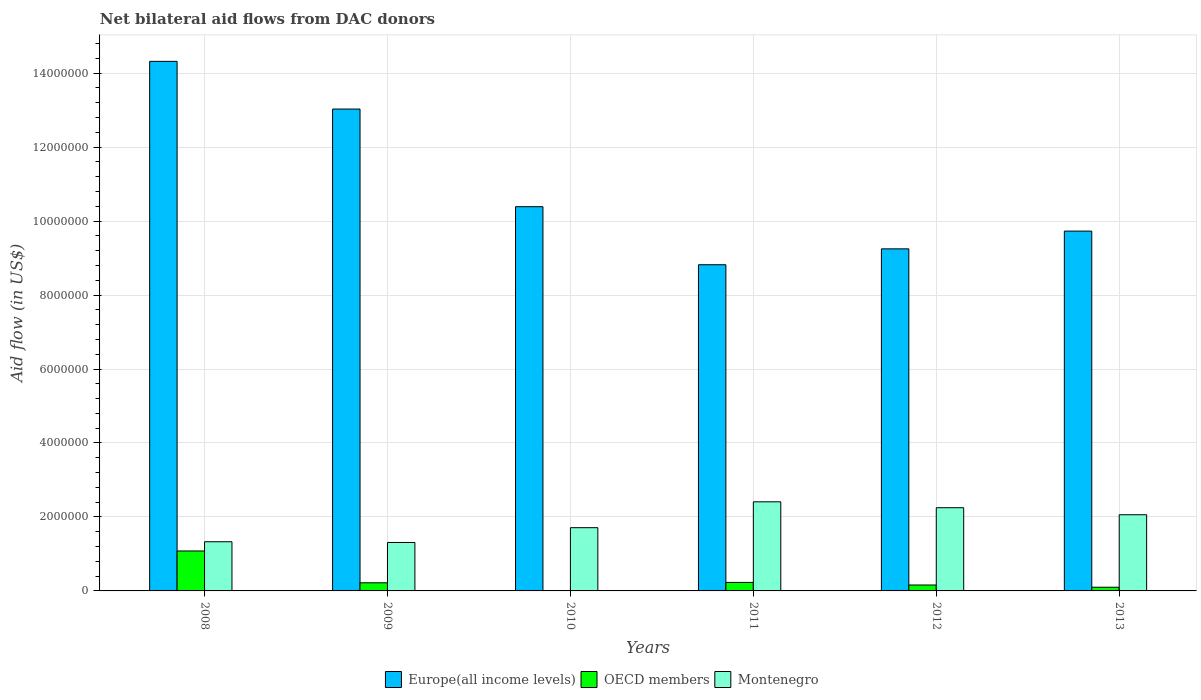How many different coloured bars are there?
Offer a very short reply. 3. How many groups of bars are there?
Offer a terse response. 6. Are the number of bars per tick equal to the number of legend labels?
Your response must be concise. Yes. Are the number of bars on each tick of the X-axis equal?
Your answer should be very brief. Yes. How many bars are there on the 1st tick from the left?
Provide a short and direct response. 3. In how many cases, is the number of bars for a given year not equal to the number of legend labels?
Ensure brevity in your answer.  0. What is the net bilateral aid flow in Europe(all income levels) in 2013?
Your response must be concise. 9.73e+06. Across all years, what is the maximum net bilateral aid flow in OECD members?
Make the answer very short. 1.08e+06. Across all years, what is the minimum net bilateral aid flow in Montenegro?
Offer a very short reply. 1.31e+06. What is the total net bilateral aid flow in Montenegro in the graph?
Keep it short and to the point. 1.11e+07. What is the difference between the net bilateral aid flow in OECD members in 2011 and that in 2013?
Give a very brief answer. 1.30e+05. What is the difference between the net bilateral aid flow in Europe(all income levels) in 2009 and the net bilateral aid flow in Montenegro in 2012?
Your response must be concise. 1.08e+07. In the year 2012, what is the difference between the net bilateral aid flow in OECD members and net bilateral aid flow in Europe(all income levels)?
Provide a short and direct response. -9.09e+06. What is the ratio of the net bilateral aid flow in OECD members in 2011 to that in 2012?
Provide a short and direct response. 1.44. Is the net bilateral aid flow in Montenegro in 2009 less than that in 2012?
Make the answer very short. Yes. Is the difference between the net bilateral aid flow in OECD members in 2008 and 2012 greater than the difference between the net bilateral aid flow in Europe(all income levels) in 2008 and 2012?
Provide a succinct answer. No. What is the difference between the highest and the second highest net bilateral aid flow in OECD members?
Your answer should be compact. 8.50e+05. What is the difference between the highest and the lowest net bilateral aid flow in OECD members?
Provide a succinct answer. 1.07e+06. In how many years, is the net bilateral aid flow in Montenegro greater than the average net bilateral aid flow in Montenegro taken over all years?
Provide a short and direct response. 3. Is the sum of the net bilateral aid flow in Europe(all income levels) in 2011 and 2013 greater than the maximum net bilateral aid flow in OECD members across all years?
Provide a short and direct response. Yes. What does the 3rd bar from the left in 2011 represents?
Your answer should be compact. Montenegro. What does the 3rd bar from the right in 2008 represents?
Give a very brief answer. Europe(all income levels). How many years are there in the graph?
Your response must be concise. 6. What is the difference between two consecutive major ticks on the Y-axis?
Offer a very short reply. 2.00e+06. Are the values on the major ticks of Y-axis written in scientific E-notation?
Offer a terse response. No. Does the graph contain any zero values?
Provide a succinct answer. No. Where does the legend appear in the graph?
Offer a very short reply. Bottom center. How are the legend labels stacked?
Offer a very short reply. Horizontal. What is the title of the graph?
Make the answer very short. Net bilateral aid flows from DAC donors. Does "High income" appear as one of the legend labels in the graph?
Keep it short and to the point. No. What is the label or title of the X-axis?
Your answer should be very brief. Years. What is the label or title of the Y-axis?
Make the answer very short. Aid flow (in US$). What is the Aid flow (in US$) of Europe(all income levels) in 2008?
Make the answer very short. 1.43e+07. What is the Aid flow (in US$) in OECD members in 2008?
Provide a succinct answer. 1.08e+06. What is the Aid flow (in US$) of Montenegro in 2008?
Provide a short and direct response. 1.33e+06. What is the Aid flow (in US$) of Europe(all income levels) in 2009?
Make the answer very short. 1.30e+07. What is the Aid flow (in US$) of Montenegro in 2009?
Offer a terse response. 1.31e+06. What is the Aid flow (in US$) of Europe(all income levels) in 2010?
Keep it short and to the point. 1.04e+07. What is the Aid flow (in US$) in OECD members in 2010?
Your answer should be compact. 10000. What is the Aid flow (in US$) in Montenegro in 2010?
Keep it short and to the point. 1.71e+06. What is the Aid flow (in US$) of Europe(all income levels) in 2011?
Offer a very short reply. 8.82e+06. What is the Aid flow (in US$) in Montenegro in 2011?
Make the answer very short. 2.41e+06. What is the Aid flow (in US$) in Europe(all income levels) in 2012?
Your response must be concise. 9.25e+06. What is the Aid flow (in US$) in OECD members in 2012?
Provide a succinct answer. 1.60e+05. What is the Aid flow (in US$) in Montenegro in 2012?
Keep it short and to the point. 2.25e+06. What is the Aid flow (in US$) of Europe(all income levels) in 2013?
Provide a short and direct response. 9.73e+06. What is the Aid flow (in US$) in OECD members in 2013?
Ensure brevity in your answer.  1.00e+05. What is the Aid flow (in US$) in Montenegro in 2013?
Your answer should be very brief. 2.06e+06. Across all years, what is the maximum Aid flow (in US$) of Europe(all income levels)?
Your answer should be very brief. 1.43e+07. Across all years, what is the maximum Aid flow (in US$) in OECD members?
Your answer should be compact. 1.08e+06. Across all years, what is the maximum Aid flow (in US$) in Montenegro?
Offer a terse response. 2.41e+06. Across all years, what is the minimum Aid flow (in US$) in Europe(all income levels)?
Make the answer very short. 8.82e+06. Across all years, what is the minimum Aid flow (in US$) in OECD members?
Your answer should be very brief. 10000. Across all years, what is the minimum Aid flow (in US$) in Montenegro?
Your answer should be compact. 1.31e+06. What is the total Aid flow (in US$) in Europe(all income levels) in the graph?
Offer a terse response. 6.55e+07. What is the total Aid flow (in US$) in OECD members in the graph?
Make the answer very short. 1.80e+06. What is the total Aid flow (in US$) of Montenegro in the graph?
Provide a short and direct response. 1.11e+07. What is the difference between the Aid flow (in US$) in Europe(all income levels) in 2008 and that in 2009?
Ensure brevity in your answer.  1.29e+06. What is the difference between the Aid flow (in US$) in OECD members in 2008 and that in 2009?
Provide a short and direct response. 8.60e+05. What is the difference between the Aid flow (in US$) in Europe(all income levels) in 2008 and that in 2010?
Provide a short and direct response. 3.93e+06. What is the difference between the Aid flow (in US$) in OECD members in 2008 and that in 2010?
Provide a short and direct response. 1.07e+06. What is the difference between the Aid flow (in US$) in Montenegro in 2008 and that in 2010?
Ensure brevity in your answer.  -3.80e+05. What is the difference between the Aid flow (in US$) of Europe(all income levels) in 2008 and that in 2011?
Give a very brief answer. 5.50e+06. What is the difference between the Aid flow (in US$) in OECD members in 2008 and that in 2011?
Offer a terse response. 8.50e+05. What is the difference between the Aid flow (in US$) in Montenegro in 2008 and that in 2011?
Offer a very short reply. -1.08e+06. What is the difference between the Aid flow (in US$) in Europe(all income levels) in 2008 and that in 2012?
Your answer should be compact. 5.07e+06. What is the difference between the Aid flow (in US$) of OECD members in 2008 and that in 2012?
Provide a short and direct response. 9.20e+05. What is the difference between the Aid flow (in US$) in Montenegro in 2008 and that in 2012?
Your answer should be very brief. -9.20e+05. What is the difference between the Aid flow (in US$) in Europe(all income levels) in 2008 and that in 2013?
Make the answer very short. 4.59e+06. What is the difference between the Aid flow (in US$) of OECD members in 2008 and that in 2013?
Your answer should be very brief. 9.80e+05. What is the difference between the Aid flow (in US$) of Montenegro in 2008 and that in 2013?
Provide a succinct answer. -7.30e+05. What is the difference between the Aid flow (in US$) of Europe(all income levels) in 2009 and that in 2010?
Offer a terse response. 2.64e+06. What is the difference between the Aid flow (in US$) of OECD members in 2009 and that in 2010?
Ensure brevity in your answer.  2.10e+05. What is the difference between the Aid flow (in US$) in Montenegro in 2009 and that in 2010?
Give a very brief answer. -4.00e+05. What is the difference between the Aid flow (in US$) in Europe(all income levels) in 2009 and that in 2011?
Your response must be concise. 4.21e+06. What is the difference between the Aid flow (in US$) of OECD members in 2009 and that in 2011?
Provide a succinct answer. -10000. What is the difference between the Aid flow (in US$) of Montenegro in 2009 and that in 2011?
Offer a very short reply. -1.10e+06. What is the difference between the Aid flow (in US$) of Europe(all income levels) in 2009 and that in 2012?
Your answer should be very brief. 3.78e+06. What is the difference between the Aid flow (in US$) in Montenegro in 2009 and that in 2012?
Your response must be concise. -9.40e+05. What is the difference between the Aid flow (in US$) in Europe(all income levels) in 2009 and that in 2013?
Provide a short and direct response. 3.30e+06. What is the difference between the Aid flow (in US$) in Montenegro in 2009 and that in 2013?
Offer a very short reply. -7.50e+05. What is the difference between the Aid flow (in US$) of Europe(all income levels) in 2010 and that in 2011?
Keep it short and to the point. 1.57e+06. What is the difference between the Aid flow (in US$) of Montenegro in 2010 and that in 2011?
Your response must be concise. -7.00e+05. What is the difference between the Aid flow (in US$) in Europe(all income levels) in 2010 and that in 2012?
Offer a terse response. 1.14e+06. What is the difference between the Aid flow (in US$) of Montenegro in 2010 and that in 2012?
Keep it short and to the point. -5.40e+05. What is the difference between the Aid flow (in US$) of Montenegro in 2010 and that in 2013?
Provide a short and direct response. -3.50e+05. What is the difference between the Aid flow (in US$) of Europe(all income levels) in 2011 and that in 2012?
Give a very brief answer. -4.30e+05. What is the difference between the Aid flow (in US$) of OECD members in 2011 and that in 2012?
Ensure brevity in your answer.  7.00e+04. What is the difference between the Aid flow (in US$) in Montenegro in 2011 and that in 2012?
Make the answer very short. 1.60e+05. What is the difference between the Aid flow (in US$) of Europe(all income levels) in 2011 and that in 2013?
Your response must be concise. -9.10e+05. What is the difference between the Aid flow (in US$) in OECD members in 2011 and that in 2013?
Give a very brief answer. 1.30e+05. What is the difference between the Aid flow (in US$) of Europe(all income levels) in 2012 and that in 2013?
Your response must be concise. -4.80e+05. What is the difference between the Aid flow (in US$) of Montenegro in 2012 and that in 2013?
Your response must be concise. 1.90e+05. What is the difference between the Aid flow (in US$) in Europe(all income levels) in 2008 and the Aid flow (in US$) in OECD members in 2009?
Make the answer very short. 1.41e+07. What is the difference between the Aid flow (in US$) of Europe(all income levels) in 2008 and the Aid flow (in US$) of Montenegro in 2009?
Offer a terse response. 1.30e+07. What is the difference between the Aid flow (in US$) in OECD members in 2008 and the Aid flow (in US$) in Montenegro in 2009?
Your answer should be very brief. -2.30e+05. What is the difference between the Aid flow (in US$) in Europe(all income levels) in 2008 and the Aid flow (in US$) in OECD members in 2010?
Provide a succinct answer. 1.43e+07. What is the difference between the Aid flow (in US$) in Europe(all income levels) in 2008 and the Aid flow (in US$) in Montenegro in 2010?
Keep it short and to the point. 1.26e+07. What is the difference between the Aid flow (in US$) in OECD members in 2008 and the Aid flow (in US$) in Montenegro in 2010?
Offer a terse response. -6.30e+05. What is the difference between the Aid flow (in US$) of Europe(all income levels) in 2008 and the Aid flow (in US$) of OECD members in 2011?
Provide a succinct answer. 1.41e+07. What is the difference between the Aid flow (in US$) in Europe(all income levels) in 2008 and the Aid flow (in US$) in Montenegro in 2011?
Give a very brief answer. 1.19e+07. What is the difference between the Aid flow (in US$) in OECD members in 2008 and the Aid flow (in US$) in Montenegro in 2011?
Keep it short and to the point. -1.33e+06. What is the difference between the Aid flow (in US$) in Europe(all income levels) in 2008 and the Aid flow (in US$) in OECD members in 2012?
Give a very brief answer. 1.42e+07. What is the difference between the Aid flow (in US$) in Europe(all income levels) in 2008 and the Aid flow (in US$) in Montenegro in 2012?
Provide a succinct answer. 1.21e+07. What is the difference between the Aid flow (in US$) in OECD members in 2008 and the Aid flow (in US$) in Montenegro in 2012?
Your response must be concise. -1.17e+06. What is the difference between the Aid flow (in US$) in Europe(all income levels) in 2008 and the Aid flow (in US$) in OECD members in 2013?
Your answer should be compact. 1.42e+07. What is the difference between the Aid flow (in US$) of Europe(all income levels) in 2008 and the Aid flow (in US$) of Montenegro in 2013?
Give a very brief answer. 1.23e+07. What is the difference between the Aid flow (in US$) of OECD members in 2008 and the Aid flow (in US$) of Montenegro in 2013?
Provide a short and direct response. -9.80e+05. What is the difference between the Aid flow (in US$) in Europe(all income levels) in 2009 and the Aid flow (in US$) in OECD members in 2010?
Offer a very short reply. 1.30e+07. What is the difference between the Aid flow (in US$) in Europe(all income levels) in 2009 and the Aid flow (in US$) in Montenegro in 2010?
Your response must be concise. 1.13e+07. What is the difference between the Aid flow (in US$) in OECD members in 2009 and the Aid flow (in US$) in Montenegro in 2010?
Provide a succinct answer. -1.49e+06. What is the difference between the Aid flow (in US$) of Europe(all income levels) in 2009 and the Aid flow (in US$) of OECD members in 2011?
Provide a short and direct response. 1.28e+07. What is the difference between the Aid flow (in US$) in Europe(all income levels) in 2009 and the Aid flow (in US$) in Montenegro in 2011?
Your answer should be compact. 1.06e+07. What is the difference between the Aid flow (in US$) in OECD members in 2009 and the Aid flow (in US$) in Montenegro in 2011?
Offer a very short reply. -2.19e+06. What is the difference between the Aid flow (in US$) of Europe(all income levels) in 2009 and the Aid flow (in US$) of OECD members in 2012?
Your answer should be compact. 1.29e+07. What is the difference between the Aid flow (in US$) of Europe(all income levels) in 2009 and the Aid flow (in US$) of Montenegro in 2012?
Offer a terse response. 1.08e+07. What is the difference between the Aid flow (in US$) in OECD members in 2009 and the Aid flow (in US$) in Montenegro in 2012?
Ensure brevity in your answer.  -2.03e+06. What is the difference between the Aid flow (in US$) in Europe(all income levels) in 2009 and the Aid flow (in US$) in OECD members in 2013?
Your answer should be compact. 1.29e+07. What is the difference between the Aid flow (in US$) in Europe(all income levels) in 2009 and the Aid flow (in US$) in Montenegro in 2013?
Offer a very short reply. 1.10e+07. What is the difference between the Aid flow (in US$) in OECD members in 2009 and the Aid flow (in US$) in Montenegro in 2013?
Your answer should be very brief. -1.84e+06. What is the difference between the Aid flow (in US$) in Europe(all income levels) in 2010 and the Aid flow (in US$) in OECD members in 2011?
Make the answer very short. 1.02e+07. What is the difference between the Aid flow (in US$) of Europe(all income levels) in 2010 and the Aid flow (in US$) of Montenegro in 2011?
Offer a terse response. 7.98e+06. What is the difference between the Aid flow (in US$) of OECD members in 2010 and the Aid flow (in US$) of Montenegro in 2011?
Your answer should be compact. -2.40e+06. What is the difference between the Aid flow (in US$) of Europe(all income levels) in 2010 and the Aid flow (in US$) of OECD members in 2012?
Give a very brief answer. 1.02e+07. What is the difference between the Aid flow (in US$) of Europe(all income levels) in 2010 and the Aid flow (in US$) of Montenegro in 2012?
Your answer should be very brief. 8.14e+06. What is the difference between the Aid flow (in US$) of OECD members in 2010 and the Aid flow (in US$) of Montenegro in 2012?
Make the answer very short. -2.24e+06. What is the difference between the Aid flow (in US$) in Europe(all income levels) in 2010 and the Aid flow (in US$) in OECD members in 2013?
Provide a succinct answer. 1.03e+07. What is the difference between the Aid flow (in US$) of Europe(all income levels) in 2010 and the Aid flow (in US$) of Montenegro in 2013?
Give a very brief answer. 8.33e+06. What is the difference between the Aid flow (in US$) of OECD members in 2010 and the Aid flow (in US$) of Montenegro in 2013?
Ensure brevity in your answer.  -2.05e+06. What is the difference between the Aid flow (in US$) of Europe(all income levels) in 2011 and the Aid flow (in US$) of OECD members in 2012?
Ensure brevity in your answer.  8.66e+06. What is the difference between the Aid flow (in US$) of Europe(all income levels) in 2011 and the Aid flow (in US$) of Montenegro in 2012?
Make the answer very short. 6.57e+06. What is the difference between the Aid flow (in US$) of OECD members in 2011 and the Aid flow (in US$) of Montenegro in 2012?
Ensure brevity in your answer.  -2.02e+06. What is the difference between the Aid flow (in US$) of Europe(all income levels) in 2011 and the Aid flow (in US$) of OECD members in 2013?
Give a very brief answer. 8.72e+06. What is the difference between the Aid flow (in US$) in Europe(all income levels) in 2011 and the Aid flow (in US$) in Montenegro in 2013?
Your answer should be compact. 6.76e+06. What is the difference between the Aid flow (in US$) in OECD members in 2011 and the Aid flow (in US$) in Montenegro in 2013?
Provide a succinct answer. -1.83e+06. What is the difference between the Aid flow (in US$) in Europe(all income levels) in 2012 and the Aid flow (in US$) in OECD members in 2013?
Provide a short and direct response. 9.15e+06. What is the difference between the Aid flow (in US$) in Europe(all income levels) in 2012 and the Aid flow (in US$) in Montenegro in 2013?
Your response must be concise. 7.19e+06. What is the difference between the Aid flow (in US$) of OECD members in 2012 and the Aid flow (in US$) of Montenegro in 2013?
Keep it short and to the point. -1.90e+06. What is the average Aid flow (in US$) of Europe(all income levels) per year?
Make the answer very short. 1.09e+07. What is the average Aid flow (in US$) of OECD members per year?
Keep it short and to the point. 3.00e+05. What is the average Aid flow (in US$) of Montenegro per year?
Your answer should be very brief. 1.84e+06. In the year 2008, what is the difference between the Aid flow (in US$) of Europe(all income levels) and Aid flow (in US$) of OECD members?
Provide a succinct answer. 1.32e+07. In the year 2008, what is the difference between the Aid flow (in US$) in Europe(all income levels) and Aid flow (in US$) in Montenegro?
Offer a very short reply. 1.30e+07. In the year 2009, what is the difference between the Aid flow (in US$) in Europe(all income levels) and Aid flow (in US$) in OECD members?
Make the answer very short. 1.28e+07. In the year 2009, what is the difference between the Aid flow (in US$) in Europe(all income levels) and Aid flow (in US$) in Montenegro?
Give a very brief answer. 1.17e+07. In the year 2009, what is the difference between the Aid flow (in US$) of OECD members and Aid flow (in US$) of Montenegro?
Give a very brief answer. -1.09e+06. In the year 2010, what is the difference between the Aid flow (in US$) of Europe(all income levels) and Aid flow (in US$) of OECD members?
Keep it short and to the point. 1.04e+07. In the year 2010, what is the difference between the Aid flow (in US$) of Europe(all income levels) and Aid flow (in US$) of Montenegro?
Your response must be concise. 8.68e+06. In the year 2010, what is the difference between the Aid flow (in US$) of OECD members and Aid flow (in US$) of Montenegro?
Ensure brevity in your answer.  -1.70e+06. In the year 2011, what is the difference between the Aid flow (in US$) of Europe(all income levels) and Aid flow (in US$) of OECD members?
Provide a succinct answer. 8.59e+06. In the year 2011, what is the difference between the Aid flow (in US$) in Europe(all income levels) and Aid flow (in US$) in Montenegro?
Provide a short and direct response. 6.41e+06. In the year 2011, what is the difference between the Aid flow (in US$) in OECD members and Aid flow (in US$) in Montenegro?
Offer a very short reply. -2.18e+06. In the year 2012, what is the difference between the Aid flow (in US$) in Europe(all income levels) and Aid flow (in US$) in OECD members?
Provide a succinct answer. 9.09e+06. In the year 2012, what is the difference between the Aid flow (in US$) of OECD members and Aid flow (in US$) of Montenegro?
Keep it short and to the point. -2.09e+06. In the year 2013, what is the difference between the Aid flow (in US$) in Europe(all income levels) and Aid flow (in US$) in OECD members?
Your answer should be compact. 9.63e+06. In the year 2013, what is the difference between the Aid flow (in US$) of Europe(all income levels) and Aid flow (in US$) of Montenegro?
Offer a terse response. 7.67e+06. In the year 2013, what is the difference between the Aid flow (in US$) in OECD members and Aid flow (in US$) in Montenegro?
Offer a very short reply. -1.96e+06. What is the ratio of the Aid flow (in US$) of Europe(all income levels) in 2008 to that in 2009?
Your answer should be compact. 1.1. What is the ratio of the Aid flow (in US$) of OECD members in 2008 to that in 2009?
Your answer should be compact. 4.91. What is the ratio of the Aid flow (in US$) in Montenegro in 2008 to that in 2009?
Give a very brief answer. 1.02. What is the ratio of the Aid flow (in US$) of Europe(all income levels) in 2008 to that in 2010?
Ensure brevity in your answer.  1.38. What is the ratio of the Aid flow (in US$) in OECD members in 2008 to that in 2010?
Offer a terse response. 108. What is the ratio of the Aid flow (in US$) in Europe(all income levels) in 2008 to that in 2011?
Provide a short and direct response. 1.62. What is the ratio of the Aid flow (in US$) in OECD members in 2008 to that in 2011?
Keep it short and to the point. 4.7. What is the ratio of the Aid flow (in US$) in Montenegro in 2008 to that in 2011?
Give a very brief answer. 0.55. What is the ratio of the Aid flow (in US$) of Europe(all income levels) in 2008 to that in 2012?
Give a very brief answer. 1.55. What is the ratio of the Aid flow (in US$) in OECD members in 2008 to that in 2012?
Give a very brief answer. 6.75. What is the ratio of the Aid flow (in US$) of Montenegro in 2008 to that in 2012?
Make the answer very short. 0.59. What is the ratio of the Aid flow (in US$) in Europe(all income levels) in 2008 to that in 2013?
Make the answer very short. 1.47. What is the ratio of the Aid flow (in US$) in OECD members in 2008 to that in 2013?
Your answer should be compact. 10.8. What is the ratio of the Aid flow (in US$) of Montenegro in 2008 to that in 2013?
Keep it short and to the point. 0.65. What is the ratio of the Aid flow (in US$) in Europe(all income levels) in 2009 to that in 2010?
Offer a terse response. 1.25. What is the ratio of the Aid flow (in US$) in Montenegro in 2009 to that in 2010?
Your answer should be very brief. 0.77. What is the ratio of the Aid flow (in US$) in Europe(all income levels) in 2009 to that in 2011?
Give a very brief answer. 1.48. What is the ratio of the Aid flow (in US$) of OECD members in 2009 to that in 2011?
Offer a terse response. 0.96. What is the ratio of the Aid flow (in US$) in Montenegro in 2009 to that in 2011?
Ensure brevity in your answer.  0.54. What is the ratio of the Aid flow (in US$) of Europe(all income levels) in 2009 to that in 2012?
Give a very brief answer. 1.41. What is the ratio of the Aid flow (in US$) in OECD members in 2009 to that in 2012?
Your response must be concise. 1.38. What is the ratio of the Aid flow (in US$) of Montenegro in 2009 to that in 2012?
Provide a succinct answer. 0.58. What is the ratio of the Aid flow (in US$) in Europe(all income levels) in 2009 to that in 2013?
Offer a terse response. 1.34. What is the ratio of the Aid flow (in US$) of OECD members in 2009 to that in 2013?
Give a very brief answer. 2.2. What is the ratio of the Aid flow (in US$) of Montenegro in 2009 to that in 2013?
Provide a short and direct response. 0.64. What is the ratio of the Aid flow (in US$) of Europe(all income levels) in 2010 to that in 2011?
Provide a succinct answer. 1.18. What is the ratio of the Aid flow (in US$) of OECD members in 2010 to that in 2011?
Ensure brevity in your answer.  0.04. What is the ratio of the Aid flow (in US$) in Montenegro in 2010 to that in 2011?
Your answer should be very brief. 0.71. What is the ratio of the Aid flow (in US$) of Europe(all income levels) in 2010 to that in 2012?
Offer a very short reply. 1.12. What is the ratio of the Aid flow (in US$) in OECD members in 2010 to that in 2012?
Keep it short and to the point. 0.06. What is the ratio of the Aid flow (in US$) in Montenegro in 2010 to that in 2012?
Offer a terse response. 0.76. What is the ratio of the Aid flow (in US$) in Europe(all income levels) in 2010 to that in 2013?
Make the answer very short. 1.07. What is the ratio of the Aid flow (in US$) of OECD members in 2010 to that in 2013?
Give a very brief answer. 0.1. What is the ratio of the Aid flow (in US$) in Montenegro in 2010 to that in 2013?
Your response must be concise. 0.83. What is the ratio of the Aid flow (in US$) of Europe(all income levels) in 2011 to that in 2012?
Make the answer very short. 0.95. What is the ratio of the Aid flow (in US$) in OECD members in 2011 to that in 2012?
Provide a short and direct response. 1.44. What is the ratio of the Aid flow (in US$) of Montenegro in 2011 to that in 2012?
Keep it short and to the point. 1.07. What is the ratio of the Aid flow (in US$) of Europe(all income levels) in 2011 to that in 2013?
Keep it short and to the point. 0.91. What is the ratio of the Aid flow (in US$) of Montenegro in 2011 to that in 2013?
Give a very brief answer. 1.17. What is the ratio of the Aid flow (in US$) of Europe(all income levels) in 2012 to that in 2013?
Keep it short and to the point. 0.95. What is the ratio of the Aid flow (in US$) in Montenegro in 2012 to that in 2013?
Offer a terse response. 1.09. What is the difference between the highest and the second highest Aid flow (in US$) in Europe(all income levels)?
Provide a succinct answer. 1.29e+06. What is the difference between the highest and the second highest Aid flow (in US$) in OECD members?
Provide a short and direct response. 8.50e+05. What is the difference between the highest and the second highest Aid flow (in US$) in Montenegro?
Keep it short and to the point. 1.60e+05. What is the difference between the highest and the lowest Aid flow (in US$) in Europe(all income levels)?
Make the answer very short. 5.50e+06. What is the difference between the highest and the lowest Aid flow (in US$) in OECD members?
Keep it short and to the point. 1.07e+06. What is the difference between the highest and the lowest Aid flow (in US$) of Montenegro?
Give a very brief answer. 1.10e+06. 